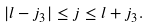Convert formula to latex. <formula><loc_0><loc_0><loc_500><loc_500>| l - j _ { 3 } | \leq j \leq l + j _ { 3 } .</formula> 